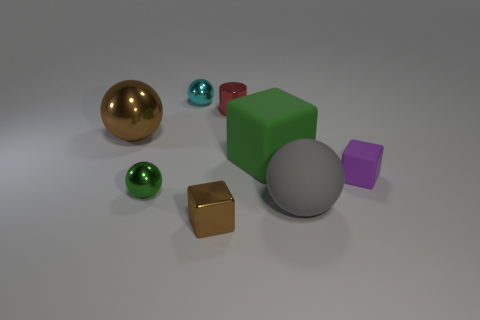How many large things are either green objects or brown matte cylinders?
Your answer should be compact. 1. What material is the small brown thing?
Your response must be concise. Metal. What number of other things are there of the same shape as the large gray object?
Make the answer very short. 3. What size is the brown metal block?
Offer a terse response. Small. There is a ball that is right of the green metal sphere and in front of the cyan sphere; what size is it?
Your response must be concise. Large. There is a small object to the right of the metal cylinder; what shape is it?
Offer a very short reply. Cube. Is the material of the purple block the same as the small block in front of the big gray sphere?
Offer a very short reply. No. Is the large metal thing the same shape as the gray rubber object?
Ensure brevity in your answer.  Yes. There is another small brown thing that is the same shape as the tiny rubber thing; what is its material?
Make the answer very short. Metal. There is a metallic thing that is both left of the tiny cyan metallic thing and in front of the large brown thing; what is its color?
Offer a very short reply. Green. 